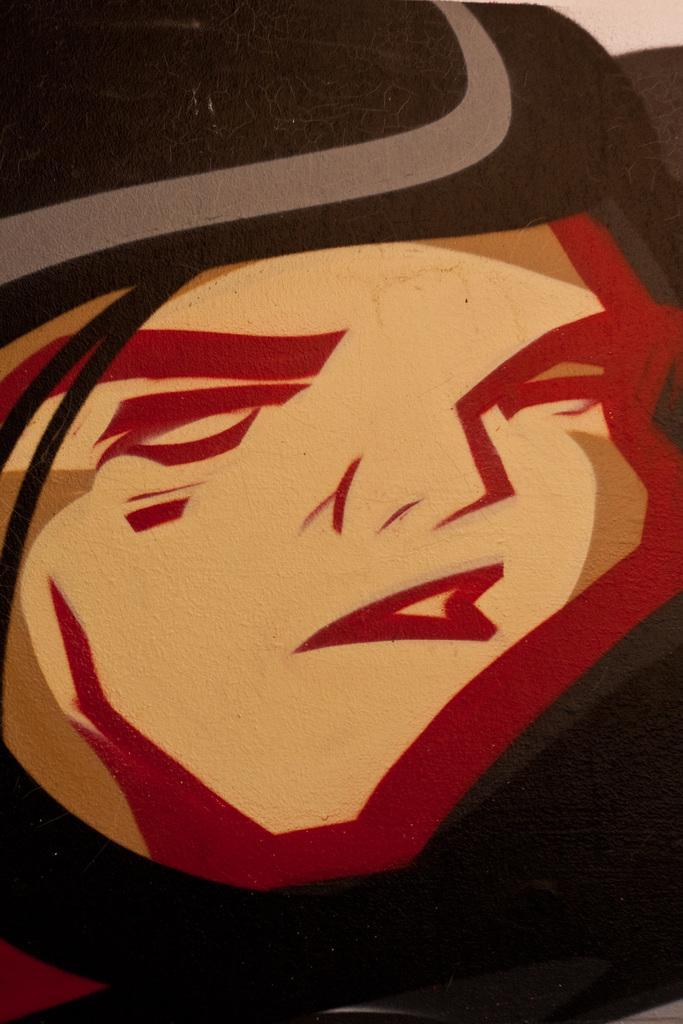Can you describe this image briefly? In this image there is a painting of a person having a hat. 